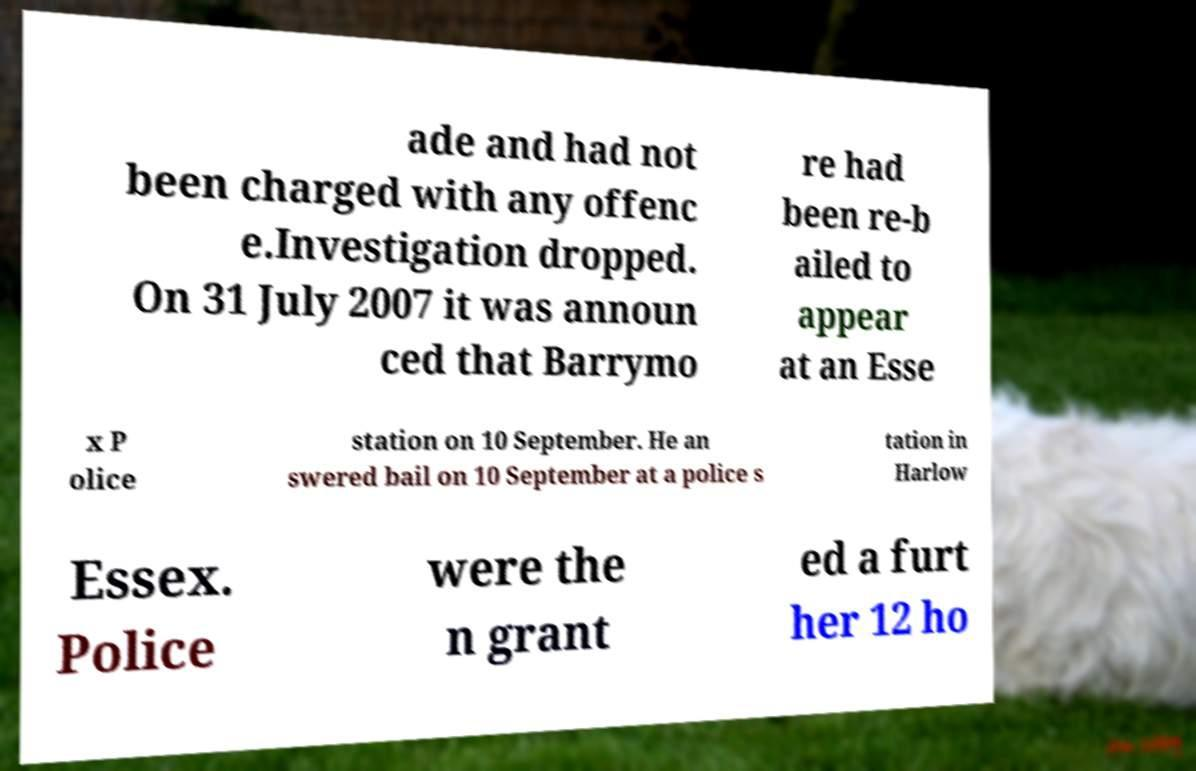Please read and relay the text visible in this image. What does it say? ade and had not been charged with any offenc e.Investigation dropped. On 31 July 2007 it was announ ced that Barrymo re had been re-b ailed to appear at an Esse x P olice station on 10 September. He an swered bail on 10 September at a police s tation in Harlow Essex. Police were the n grant ed a furt her 12 ho 